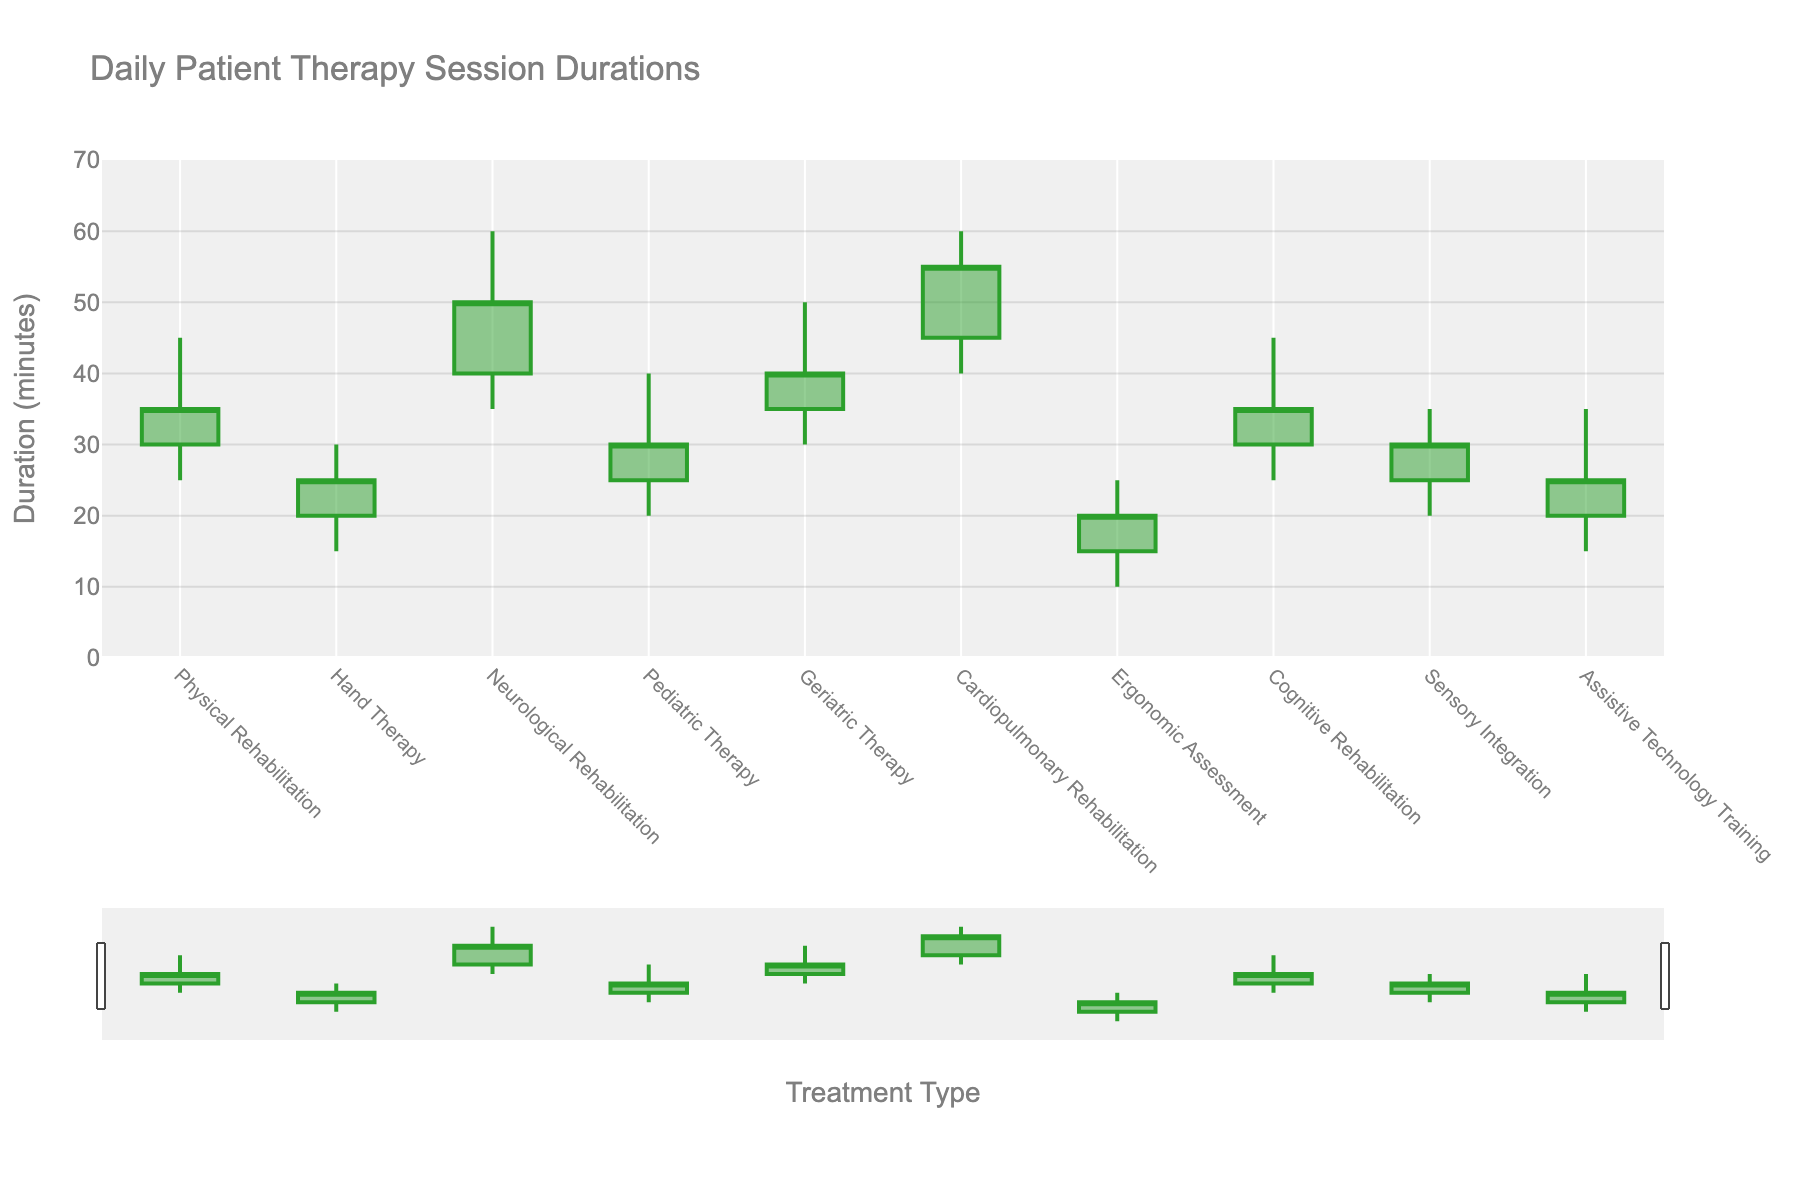What's the title of the chart? The title of the chart is displayed at the top of the figure.
Answer: Daily Patient Therapy Session Durations What is the range of the y-axis? The y-axis range can be observed on the left side of the figure, which spans from 0 to 70 minutes.
Answer: 0 to 70 Which treatment type has the largest difference between its high and low duration values? Neurological Rehabilitation has the largest difference as its high value is 60 and its low value is 35; the difference is 25 minutes.
Answer: Neurological Rehabilitation How many treatment types have an open value greater than 30 minutes? By examining each 'Open' value in the chart:
Physical Rehabilitation: 30,
Hand Therapy: 20,
Neurological Rehabilitation: 40,
Pediatric Therapy: 25,
Geriatric Therapy: 35,
Cardiopulmonary Rehabilitation: 45,
Ergonomic Assessment: 15,
Cognitive Rehabilitation: 30,
Sensory Integration: 25,
Assistive Technology Training: 20,
Only three treatment types have an open value greater than 30: 
Neurological Rehabilitation, Geriatric Therapy, and Cardiopulmonary Rehabilitation.
Answer: 3 Which therapy sessions show an increase in duration over the day (i.e., close value is higher than the open value)? Comparing the open and close values for each treatment:
Physical Rehabilitation: 30 < 35,
Hand Therapy: 20 < 25,
Neurological Rehabilitation: 40 < 50,
Pediatric Therapy: 25 < 30,
Geriatric Therapy: 35 < 40,
Cardiopulmonary Rehabilitation: 45 < 55,
Ergonomic Assessment: 15 < 20,
Cognitive Rehabilitation: 30 < 35,
Sensory Integration: 25 < 30,
Assistive Technology Training: 20 < 25,
All treatment types show an increase.
Answer: All What is the median of the closing values of all treatment types? To find the median of closing values, list them in ascending order:
20, 25, 25, 25, 30, 30, 30, 35, 40, 50, 55.
With 10 data points, the median is the average of the 5th and 6th values: 
(30 + 30) / 2 = 30.
Answer: 30 Which treatment type has the lowest 'Low' duration value? By comparing the 'Low' values, Ergonomic Assessment has the lowest value of 10 minutes.
Answer: Ergonomic Assessment What is the average high duration across all treatment types? Adding up all the high values (45+30+60+40+50+60+25+45+35+35) and dividing by the number of treatments:
(45 + 30 + 60 + 40 + 50 + 60 + 25 + 45 + 35 + 35) / 10 = 42.5.
Answer: 42.5 What is the difference between the maximum and minimum 'Close' values among all treatment types? The maximum close value is 55 (Cardiopulmonary Rehabilitation) and the minimum close value is 20 (Ergonomic Assessment), so the difference is 55 - 20.
Answer: 35 